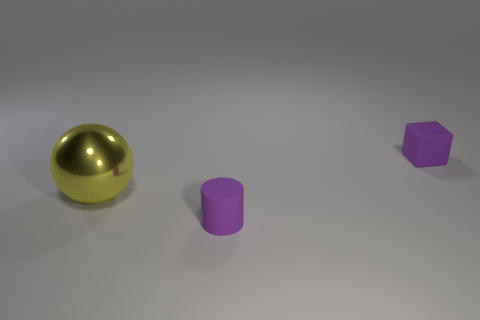Add 3 tiny brown balls. How many objects exist? 6 Subtract all large gray rubber objects. Subtract all large yellow balls. How many objects are left? 2 Add 1 spheres. How many spheres are left? 2 Add 1 tiny yellow metallic things. How many tiny yellow metallic things exist? 1 Subtract 0 blue cylinders. How many objects are left? 3 Subtract all blocks. How many objects are left? 2 Subtract all yellow cubes. Subtract all blue balls. How many cubes are left? 1 